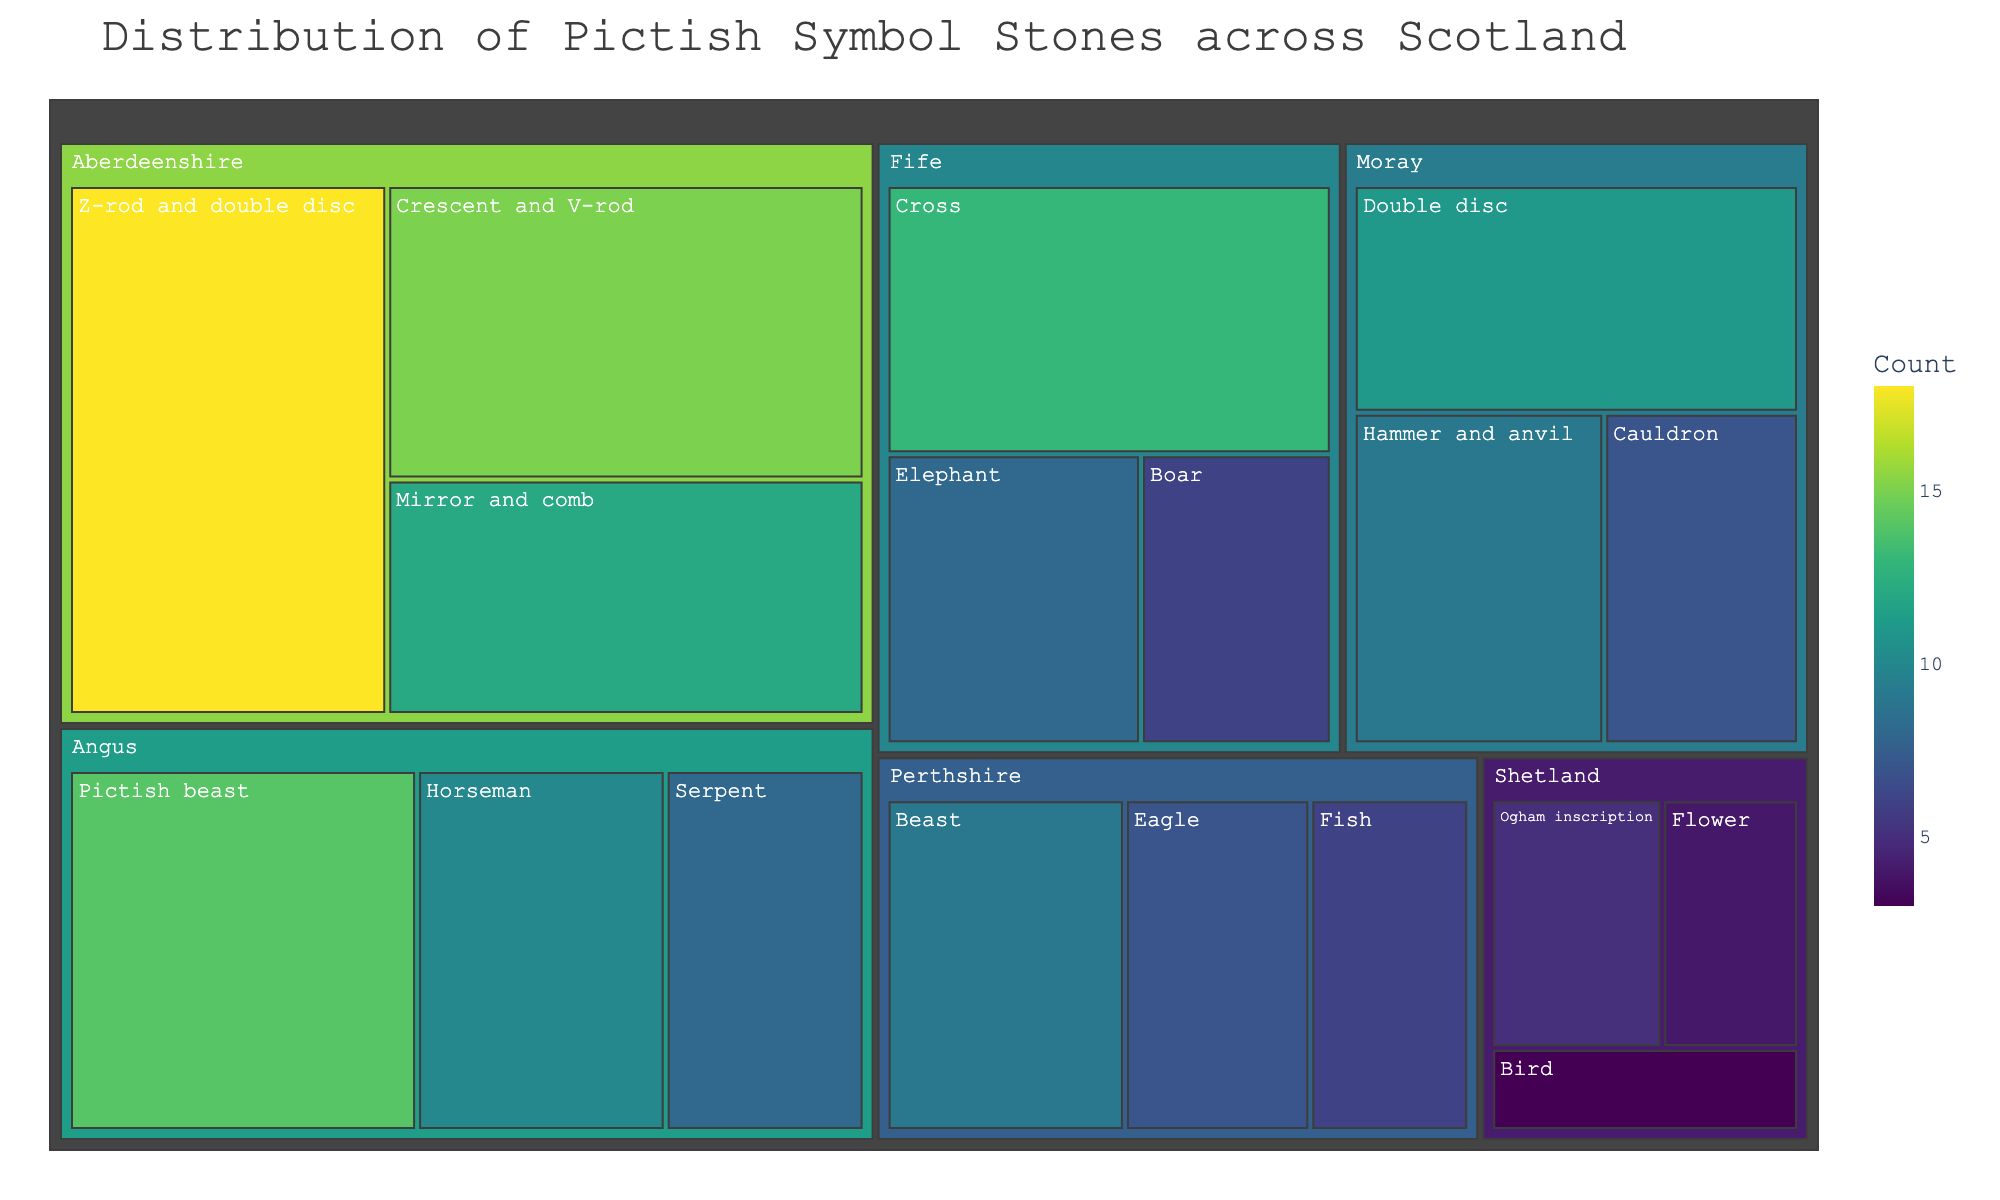Which region has the highest count of Pictish symbol stones? The region with the largest square area in the treemap represents the highest count. Aberdeenshire has the largest area.
Answer: Aberdeenshire Which symbol type in Angus has the highest count? In the Angus section of the treemap, the largest area corresponds to the "Pictish beast" symbol type.
Answer: Pictish beast What is the total count of Pictish symbol stones in Moray? Sum the counts of all symbol types in Moray (11 + 9 + 7).
Answer: 27 How does the count of the "Beast" symbol type in Perthshire compare to the "Boar" in Fife? The counts for "Beast" in Perthshire and "Boar" in Fife are visually compared. The "Beast" has a count of 9 and the "Boar" has a count of 6.
Answer: The "Beast" count is higher Which region contains the fewest symbol stones in the treemap? The region with the smallest total area is Shetland.
Answer: Shetland What is the sum of the counts for the "Mirror and comb" symbol type in Aberdeenshire and the "Serpent" in Angus? Add the counts for "Mirror and comb" (12) and "Serpent" (8).
Answer: 20 Visualize how many symbol types are listed in Perthshire and what they are. There are three distinct areas in Perthshire, representing "Beast," "Eagle," and "Fish."
Answer: Three: Beast, Eagle, Fish Compare the total count of symbol stones in Aberdeenshire with Fife. Total counts in Aberdeenshire (18 + 15 + 12) and Fife (13 + 8 + 6) are calculated.
Answer: Aberdeenshire: 45; Fife: 27 Which symbol type has the lowest count in the entire treemap? The smallest individual area within the treemap, representing "Bird" in Shetland, indicates the lowest count.
Answer: Bird What is the difference in the Pictish symbol stone counts between "Cross" in Fife and "Cauldron" in Moray? Subtract the count of "Cauldron" (7) in Moray from "Cross" (13) in Fife.
Answer: 6 